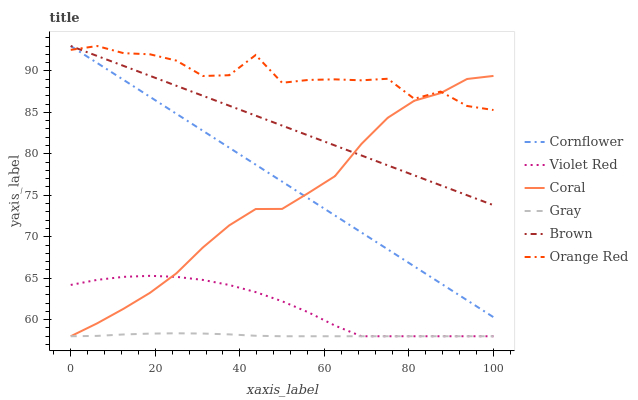Does Gray have the minimum area under the curve?
Answer yes or no. Yes. Does Orange Red have the maximum area under the curve?
Answer yes or no. Yes. Does Violet Red have the minimum area under the curve?
Answer yes or no. No. Does Violet Red have the maximum area under the curve?
Answer yes or no. No. Is Cornflower the smoothest?
Answer yes or no. Yes. Is Orange Red the roughest?
Answer yes or no. Yes. Is Violet Red the smoothest?
Answer yes or no. No. Is Violet Red the roughest?
Answer yes or no. No. Does Violet Red have the lowest value?
Answer yes or no. Yes. Does Brown have the lowest value?
Answer yes or no. No. Does Orange Red have the highest value?
Answer yes or no. Yes. Does Violet Red have the highest value?
Answer yes or no. No. Is Violet Red less than Cornflower?
Answer yes or no. Yes. Is Orange Red greater than Violet Red?
Answer yes or no. Yes. Does Brown intersect Cornflower?
Answer yes or no. Yes. Is Brown less than Cornflower?
Answer yes or no. No. Is Brown greater than Cornflower?
Answer yes or no. No. Does Violet Red intersect Cornflower?
Answer yes or no. No. 